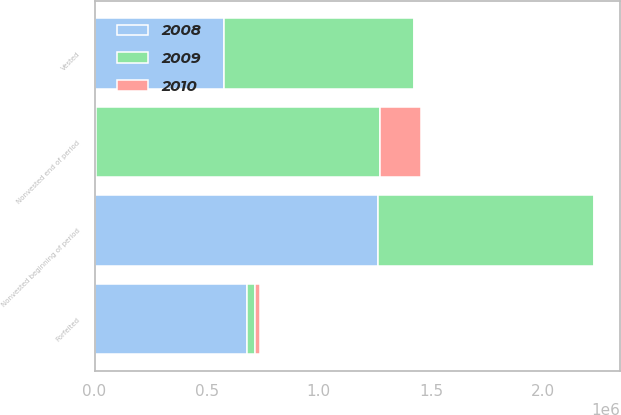<chart> <loc_0><loc_0><loc_500><loc_500><stacked_bar_chart><ecel><fcel>Nonvested beginning of period<fcel>Vested<fcel>Forfeited<fcel>Nonvested end of period<nl><fcel>2010<fcel>7500<fcel>2947<fcel>19057<fcel>184196<nl><fcel>2008<fcel>1.2635e+06<fcel>575890<fcel>680110<fcel>7500<nl><fcel>2009<fcel>962000<fcel>850500<fcel>36500<fcel>1.2635e+06<nl></chart> 